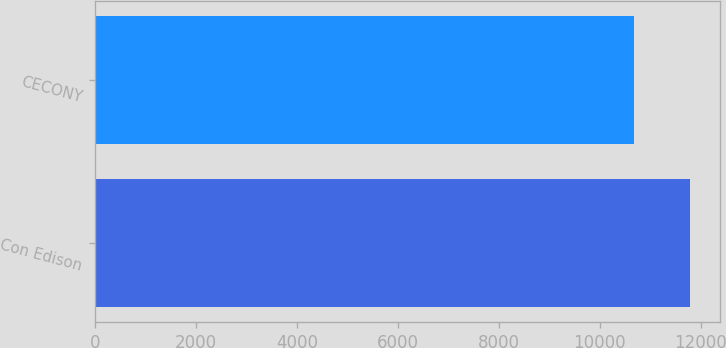<chart> <loc_0><loc_0><loc_500><loc_500><bar_chart><fcel>Con Edison<fcel>CECONY<nl><fcel>11795<fcel>10680<nl></chart> 